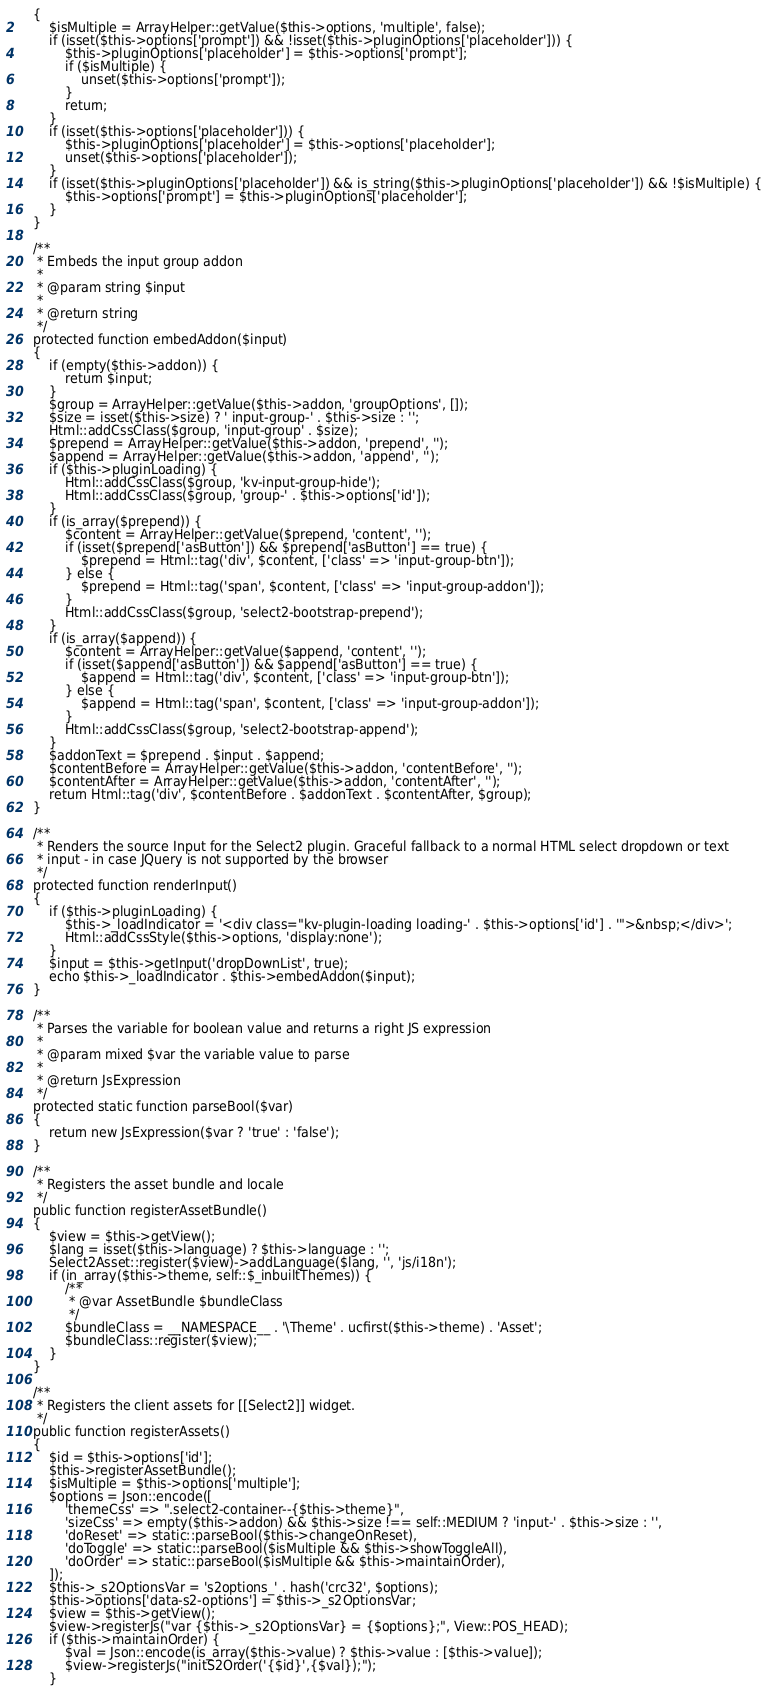<code> <loc_0><loc_0><loc_500><loc_500><_PHP_>    {
        $isMultiple = ArrayHelper::getValue($this->options, 'multiple', false);
        if (isset($this->options['prompt']) && !isset($this->pluginOptions['placeholder'])) {
            $this->pluginOptions['placeholder'] = $this->options['prompt'];
            if ($isMultiple) {
                unset($this->options['prompt']);
            }
            return;
        }
        if (isset($this->options['placeholder'])) {
            $this->pluginOptions['placeholder'] = $this->options['placeholder'];
            unset($this->options['placeholder']);
        }
        if (isset($this->pluginOptions['placeholder']) && is_string($this->pluginOptions['placeholder']) && !$isMultiple) {
            $this->options['prompt'] = $this->pluginOptions['placeholder'];
        }
    }

    /**
     * Embeds the input group addon
     *
     * @param string $input
     *
     * @return string
     */
    protected function embedAddon($input)
    {
        if (empty($this->addon)) {
            return $input;
        }
        $group = ArrayHelper::getValue($this->addon, 'groupOptions', []);
        $size = isset($this->size) ? ' input-group-' . $this->size : '';
        Html::addCssClass($group, 'input-group' . $size);
        $prepend = ArrayHelper::getValue($this->addon, 'prepend', '');
        $append = ArrayHelper::getValue($this->addon, 'append', '');
        if ($this->pluginLoading) {
            Html::addCssClass($group, 'kv-input-group-hide');
            Html::addCssClass($group, 'group-' . $this->options['id']);
        }
        if (is_array($prepend)) {
            $content = ArrayHelper::getValue($prepend, 'content', '');
            if (isset($prepend['asButton']) && $prepend['asButton'] == true) {
                $prepend = Html::tag('div', $content, ['class' => 'input-group-btn']);
            } else {
                $prepend = Html::tag('span', $content, ['class' => 'input-group-addon']);
            }
            Html::addCssClass($group, 'select2-bootstrap-prepend');
        }
        if (is_array($append)) {
            $content = ArrayHelper::getValue($append, 'content', '');
            if (isset($append['asButton']) && $append['asButton'] == true) {
                $append = Html::tag('div', $content, ['class' => 'input-group-btn']);
            } else {
                $append = Html::tag('span', $content, ['class' => 'input-group-addon']);
            }
            Html::addCssClass($group, 'select2-bootstrap-append');
        }
        $addonText = $prepend . $input . $append;
        $contentBefore = ArrayHelper::getValue($this->addon, 'contentBefore', '');
        $contentAfter = ArrayHelper::getValue($this->addon, 'contentAfter', '');
        return Html::tag('div', $contentBefore . $addonText . $contentAfter, $group);
    }

    /**
     * Renders the source Input for the Select2 plugin. Graceful fallback to a normal HTML select dropdown or text
     * input - in case JQuery is not supported by the browser
     */
    protected function renderInput()
    {
        if ($this->pluginLoading) {
            $this->_loadIndicator = '<div class="kv-plugin-loading loading-' . $this->options['id'] . '">&nbsp;</div>';
            Html::addCssStyle($this->options, 'display:none');
        }
        $input = $this->getInput('dropDownList', true);
        echo $this->_loadIndicator . $this->embedAddon($input);
    }

    /**
     * Parses the variable for boolean value and returns a right JS expression
     *
     * @param mixed $var the variable value to parse
     *
     * @return JsExpression
     */
    protected static function parseBool($var)
    {
        return new JsExpression($var ? 'true' : 'false');
    }

    /**
     * Registers the asset bundle and locale
     */
    public function registerAssetBundle()
    {
        $view = $this->getView();
        $lang = isset($this->language) ? $this->language : '';
        Select2Asset::register($view)->addLanguage($lang, '', 'js/i18n');
        if (in_array($this->theme, self::$_inbuiltThemes)) {
            /**
             * @var AssetBundle $bundleClass
             */
            $bundleClass = __NAMESPACE__ . '\Theme' . ucfirst($this->theme) . 'Asset';
            $bundleClass::register($view);
        }
    }

    /**
     * Registers the client assets for [[Select2]] widget.
     */
    public function registerAssets()
    {
        $id = $this->options['id'];
        $this->registerAssetBundle();
        $isMultiple = $this->options['multiple'];
        $options = Json::encode([
            'themeCss' => ".select2-container--{$this->theme}",
            'sizeCss' => empty($this->addon) && $this->size !== self::MEDIUM ? 'input-' . $this->size : '',
            'doReset' => static::parseBool($this->changeOnReset),
            'doToggle' => static::parseBool($isMultiple && $this->showToggleAll),
            'doOrder' => static::parseBool($isMultiple && $this->maintainOrder),
        ]);
        $this->_s2OptionsVar = 's2options_' . hash('crc32', $options);
        $this->options['data-s2-options'] = $this->_s2OptionsVar;
        $view = $this->getView();
        $view->registerJs("var {$this->_s2OptionsVar} = {$options};", View::POS_HEAD);
        if ($this->maintainOrder) {
            $val = Json::encode(is_array($this->value) ? $this->value : [$this->value]);
            $view->registerJs("initS2Order('{$id}',{$val});");
        }</code> 